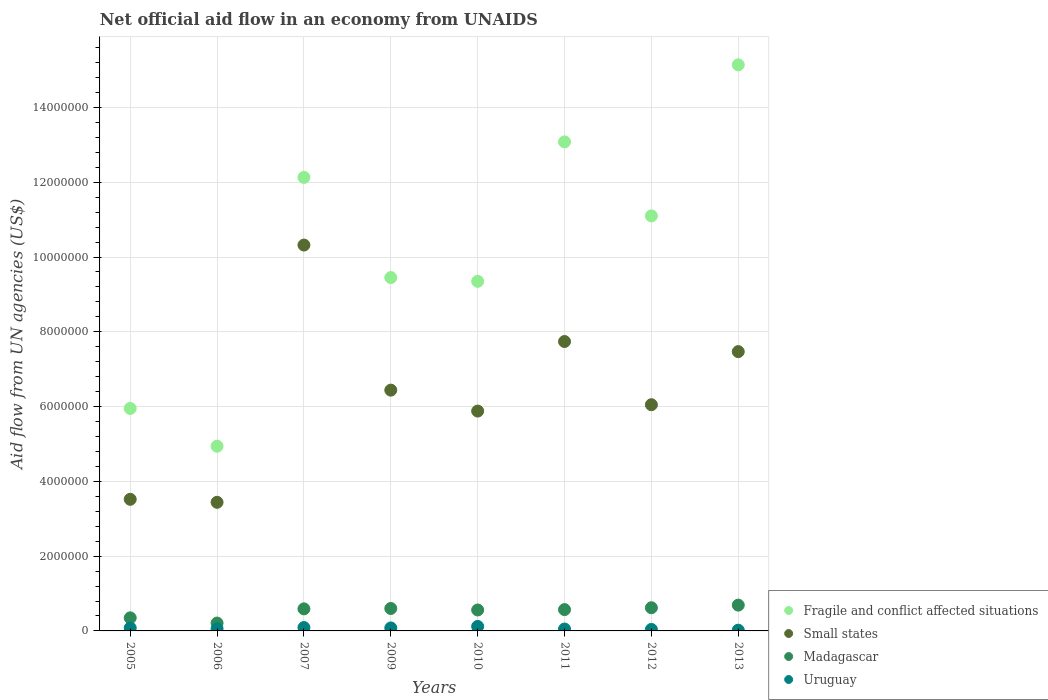How many different coloured dotlines are there?
Make the answer very short. 4. What is the net official aid flow in Fragile and conflict affected situations in 2012?
Your response must be concise. 1.11e+07. Across all years, what is the maximum net official aid flow in Fragile and conflict affected situations?
Make the answer very short. 1.51e+07. Across all years, what is the minimum net official aid flow in Small states?
Keep it short and to the point. 3.44e+06. In which year was the net official aid flow in Uruguay minimum?
Keep it short and to the point. 2013. What is the total net official aid flow in Uruguay in the graph?
Your answer should be very brief. 5.40e+05. What is the difference between the net official aid flow in Madagascar in 2006 and that in 2009?
Your answer should be compact. -3.90e+05. What is the difference between the net official aid flow in Uruguay in 2006 and the net official aid flow in Madagascar in 2011?
Offer a terse response. -5.10e+05. What is the average net official aid flow in Madagascar per year?
Provide a succinct answer. 5.24e+05. In the year 2012, what is the difference between the net official aid flow in Fragile and conflict affected situations and net official aid flow in Uruguay?
Make the answer very short. 1.11e+07. In how many years, is the net official aid flow in Fragile and conflict affected situations greater than 10400000 US$?
Your response must be concise. 4. What is the ratio of the net official aid flow in Madagascar in 2011 to that in 2013?
Give a very brief answer. 0.83. What is the difference between the highest and the lowest net official aid flow in Fragile and conflict affected situations?
Make the answer very short. 1.02e+07. Is it the case that in every year, the sum of the net official aid flow in Small states and net official aid flow in Madagascar  is greater than the net official aid flow in Uruguay?
Offer a terse response. Yes. Does the net official aid flow in Fragile and conflict affected situations monotonically increase over the years?
Offer a terse response. No. What is the difference between two consecutive major ticks on the Y-axis?
Your response must be concise. 2.00e+06. Does the graph contain grids?
Your response must be concise. Yes. How many legend labels are there?
Give a very brief answer. 4. What is the title of the graph?
Offer a terse response. Net official aid flow in an economy from UNAIDS. What is the label or title of the Y-axis?
Your answer should be compact. Aid flow from UN agencies (US$). What is the Aid flow from UN agencies (US$) in Fragile and conflict affected situations in 2005?
Keep it short and to the point. 5.95e+06. What is the Aid flow from UN agencies (US$) in Small states in 2005?
Make the answer very short. 3.52e+06. What is the Aid flow from UN agencies (US$) of Madagascar in 2005?
Offer a very short reply. 3.50e+05. What is the Aid flow from UN agencies (US$) of Fragile and conflict affected situations in 2006?
Provide a short and direct response. 4.94e+06. What is the Aid flow from UN agencies (US$) in Small states in 2006?
Make the answer very short. 3.44e+06. What is the Aid flow from UN agencies (US$) in Madagascar in 2006?
Ensure brevity in your answer.  2.10e+05. What is the Aid flow from UN agencies (US$) of Uruguay in 2006?
Your answer should be very brief. 6.00e+04. What is the Aid flow from UN agencies (US$) of Fragile and conflict affected situations in 2007?
Make the answer very short. 1.21e+07. What is the Aid flow from UN agencies (US$) in Small states in 2007?
Ensure brevity in your answer.  1.03e+07. What is the Aid flow from UN agencies (US$) in Madagascar in 2007?
Your answer should be compact. 5.90e+05. What is the Aid flow from UN agencies (US$) in Uruguay in 2007?
Keep it short and to the point. 9.00e+04. What is the Aid flow from UN agencies (US$) of Fragile and conflict affected situations in 2009?
Offer a very short reply. 9.45e+06. What is the Aid flow from UN agencies (US$) in Small states in 2009?
Your answer should be compact. 6.44e+06. What is the Aid flow from UN agencies (US$) in Uruguay in 2009?
Keep it short and to the point. 8.00e+04. What is the Aid flow from UN agencies (US$) of Fragile and conflict affected situations in 2010?
Provide a succinct answer. 9.35e+06. What is the Aid flow from UN agencies (US$) of Small states in 2010?
Provide a short and direct response. 5.88e+06. What is the Aid flow from UN agencies (US$) in Madagascar in 2010?
Your response must be concise. 5.60e+05. What is the Aid flow from UN agencies (US$) in Fragile and conflict affected situations in 2011?
Give a very brief answer. 1.31e+07. What is the Aid flow from UN agencies (US$) of Small states in 2011?
Offer a terse response. 7.74e+06. What is the Aid flow from UN agencies (US$) of Madagascar in 2011?
Make the answer very short. 5.70e+05. What is the Aid flow from UN agencies (US$) in Uruguay in 2011?
Keep it short and to the point. 5.00e+04. What is the Aid flow from UN agencies (US$) of Fragile and conflict affected situations in 2012?
Offer a terse response. 1.11e+07. What is the Aid flow from UN agencies (US$) of Small states in 2012?
Provide a succinct answer. 6.05e+06. What is the Aid flow from UN agencies (US$) of Madagascar in 2012?
Give a very brief answer. 6.20e+05. What is the Aid flow from UN agencies (US$) in Uruguay in 2012?
Give a very brief answer. 4.00e+04. What is the Aid flow from UN agencies (US$) in Fragile and conflict affected situations in 2013?
Make the answer very short. 1.51e+07. What is the Aid flow from UN agencies (US$) in Small states in 2013?
Your response must be concise. 7.47e+06. What is the Aid flow from UN agencies (US$) in Madagascar in 2013?
Offer a terse response. 6.90e+05. Across all years, what is the maximum Aid flow from UN agencies (US$) in Fragile and conflict affected situations?
Your response must be concise. 1.51e+07. Across all years, what is the maximum Aid flow from UN agencies (US$) in Small states?
Keep it short and to the point. 1.03e+07. Across all years, what is the maximum Aid flow from UN agencies (US$) in Madagascar?
Give a very brief answer. 6.90e+05. Across all years, what is the minimum Aid flow from UN agencies (US$) of Fragile and conflict affected situations?
Offer a terse response. 4.94e+06. Across all years, what is the minimum Aid flow from UN agencies (US$) in Small states?
Ensure brevity in your answer.  3.44e+06. Across all years, what is the minimum Aid flow from UN agencies (US$) of Madagascar?
Offer a very short reply. 2.10e+05. Across all years, what is the minimum Aid flow from UN agencies (US$) in Uruguay?
Your answer should be very brief. 2.00e+04. What is the total Aid flow from UN agencies (US$) in Fragile and conflict affected situations in the graph?
Your answer should be very brief. 8.11e+07. What is the total Aid flow from UN agencies (US$) of Small states in the graph?
Your answer should be compact. 5.09e+07. What is the total Aid flow from UN agencies (US$) of Madagascar in the graph?
Offer a terse response. 4.19e+06. What is the total Aid flow from UN agencies (US$) in Uruguay in the graph?
Provide a short and direct response. 5.40e+05. What is the difference between the Aid flow from UN agencies (US$) of Fragile and conflict affected situations in 2005 and that in 2006?
Keep it short and to the point. 1.01e+06. What is the difference between the Aid flow from UN agencies (US$) in Small states in 2005 and that in 2006?
Give a very brief answer. 8.00e+04. What is the difference between the Aid flow from UN agencies (US$) of Fragile and conflict affected situations in 2005 and that in 2007?
Offer a terse response. -6.18e+06. What is the difference between the Aid flow from UN agencies (US$) of Small states in 2005 and that in 2007?
Give a very brief answer. -6.80e+06. What is the difference between the Aid flow from UN agencies (US$) of Fragile and conflict affected situations in 2005 and that in 2009?
Your answer should be very brief. -3.50e+06. What is the difference between the Aid flow from UN agencies (US$) of Small states in 2005 and that in 2009?
Give a very brief answer. -2.92e+06. What is the difference between the Aid flow from UN agencies (US$) in Fragile and conflict affected situations in 2005 and that in 2010?
Your answer should be very brief. -3.40e+06. What is the difference between the Aid flow from UN agencies (US$) in Small states in 2005 and that in 2010?
Make the answer very short. -2.36e+06. What is the difference between the Aid flow from UN agencies (US$) of Madagascar in 2005 and that in 2010?
Ensure brevity in your answer.  -2.10e+05. What is the difference between the Aid flow from UN agencies (US$) of Fragile and conflict affected situations in 2005 and that in 2011?
Offer a terse response. -7.13e+06. What is the difference between the Aid flow from UN agencies (US$) in Small states in 2005 and that in 2011?
Provide a short and direct response. -4.22e+06. What is the difference between the Aid flow from UN agencies (US$) in Madagascar in 2005 and that in 2011?
Keep it short and to the point. -2.20e+05. What is the difference between the Aid flow from UN agencies (US$) in Uruguay in 2005 and that in 2011?
Provide a succinct answer. 3.00e+04. What is the difference between the Aid flow from UN agencies (US$) of Fragile and conflict affected situations in 2005 and that in 2012?
Ensure brevity in your answer.  -5.15e+06. What is the difference between the Aid flow from UN agencies (US$) in Small states in 2005 and that in 2012?
Offer a very short reply. -2.53e+06. What is the difference between the Aid flow from UN agencies (US$) in Madagascar in 2005 and that in 2012?
Give a very brief answer. -2.70e+05. What is the difference between the Aid flow from UN agencies (US$) of Fragile and conflict affected situations in 2005 and that in 2013?
Ensure brevity in your answer.  -9.19e+06. What is the difference between the Aid flow from UN agencies (US$) in Small states in 2005 and that in 2013?
Provide a short and direct response. -3.95e+06. What is the difference between the Aid flow from UN agencies (US$) in Fragile and conflict affected situations in 2006 and that in 2007?
Ensure brevity in your answer.  -7.19e+06. What is the difference between the Aid flow from UN agencies (US$) in Small states in 2006 and that in 2007?
Provide a short and direct response. -6.88e+06. What is the difference between the Aid flow from UN agencies (US$) of Madagascar in 2006 and that in 2007?
Your response must be concise. -3.80e+05. What is the difference between the Aid flow from UN agencies (US$) of Fragile and conflict affected situations in 2006 and that in 2009?
Provide a short and direct response. -4.51e+06. What is the difference between the Aid flow from UN agencies (US$) of Small states in 2006 and that in 2009?
Provide a short and direct response. -3.00e+06. What is the difference between the Aid flow from UN agencies (US$) in Madagascar in 2006 and that in 2009?
Give a very brief answer. -3.90e+05. What is the difference between the Aid flow from UN agencies (US$) of Uruguay in 2006 and that in 2009?
Make the answer very short. -2.00e+04. What is the difference between the Aid flow from UN agencies (US$) of Fragile and conflict affected situations in 2006 and that in 2010?
Provide a short and direct response. -4.41e+06. What is the difference between the Aid flow from UN agencies (US$) of Small states in 2006 and that in 2010?
Your response must be concise. -2.44e+06. What is the difference between the Aid flow from UN agencies (US$) of Madagascar in 2006 and that in 2010?
Ensure brevity in your answer.  -3.50e+05. What is the difference between the Aid flow from UN agencies (US$) of Fragile and conflict affected situations in 2006 and that in 2011?
Keep it short and to the point. -8.14e+06. What is the difference between the Aid flow from UN agencies (US$) in Small states in 2006 and that in 2011?
Make the answer very short. -4.30e+06. What is the difference between the Aid flow from UN agencies (US$) in Madagascar in 2006 and that in 2011?
Your answer should be compact. -3.60e+05. What is the difference between the Aid flow from UN agencies (US$) in Uruguay in 2006 and that in 2011?
Your answer should be compact. 10000. What is the difference between the Aid flow from UN agencies (US$) of Fragile and conflict affected situations in 2006 and that in 2012?
Your answer should be compact. -6.16e+06. What is the difference between the Aid flow from UN agencies (US$) in Small states in 2006 and that in 2012?
Keep it short and to the point. -2.61e+06. What is the difference between the Aid flow from UN agencies (US$) of Madagascar in 2006 and that in 2012?
Your answer should be compact. -4.10e+05. What is the difference between the Aid flow from UN agencies (US$) in Uruguay in 2006 and that in 2012?
Offer a very short reply. 2.00e+04. What is the difference between the Aid flow from UN agencies (US$) in Fragile and conflict affected situations in 2006 and that in 2013?
Offer a terse response. -1.02e+07. What is the difference between the Aid flow from UN agencies (US$) of Small states in 2006 and that in 2013?
Make the answer very short. -4.03e+06. What is the difference between the Aid flow from UN agencies (US$) in Madagascar in 2006 and that in 2013?
Offer a terse response. -4.80e+05. What is the difference between the Aid flow from UN agencies (US$) in Uruguay in 2006 and that in 2013?
Provide a succinct answer. 4.00e+04. What is the difference between the Aid flow from UN agencies (US$) of Fragile and conflict affected situations in 2007 and that in 2009?
Provide a succinct answer. 2.68e+06. What is the difference between the Aid flow from UN agencies (US$) of Small states in 2007 and that in 2009?
Offer a terse response. 3.88e+06. What is the difference between the Aid flow from UN agencies (US$) in Uruguay in 2007 and that in 2009?
Provide a succinct answer. 10000. What is the difference between the Aid flow from UN agencies (US$) of Fragile and conflict affected situations in 2007 and that in 2010?
Ensure brevity in your answer.  2.78e+06. What is the difference between the Aid flow from UN agencies (US$) in Small states in 2007 and that in 2010?
Offer a very short reply. 4.44e+06. What is the difference between the Aid flow from UN agencies (US$) of Uruguay in 2007 and that in 2010?
Your answer should be very brief. -3.00e+04. What is the difference between the Aid flow from UN agencies (US$) of Fragile and conflict affected situations in 2007 and that in 2011?
Offer a terse response. -9.50e+05. What is the difference between the Aid flow from UN agencies (US$) of Small states in 2007 and that in 2011?
Provide a succinct answer. 2.58e+06. What is the difference between the Aid flow from UN agencies (US$) in Madagascar in 2007 and that in 2011?
Provide a succinct answer. 2.00e+04. What is the difference between the Aid flow from UN agencies (US$) of Fragile and conflict affected situations in 2007 and that in 2012?
Provide a short and direct response. 1.03e+06. What is the difference between the Aid flow from UN agencies (US$) in Small states in 2007 and that in 2012?
Your response must be concise. 4.27e+06. What is the difference between the Aid flow from UN agencies (US$) in Madagascar in 2007 and that in 2012?
Keep it short and to the point. -3.00e+04. What is the difference between the Aid flow from UN agencies (US$) in Uruguay in 2007 and that in 2012?
Keep it short and to the point. 5.00e+04. What is the difference between the Aid flow from UN agencies (US$) in Fragile and conflict affected situations in 2007 and that in 2013?
Your response must be concise. -3.01e+06. What is the difference between the Aid flow from UN agencies (US$) of Small states in 2007 and that in 2013?
Give a very brief answer. 2.85e+06. What is the difference between the Aid flow from UN agencies (US$) in Madagascar in 2007 and that in 2013?
Offer a very short reply. -1.00e+05. What is the difference between the Aid flow from UN agencies (US$) of Small states in 2009 and that in 2010?
Your response must be concise. 5.60e+05. What is the difference between the Aid flow from UN agencies (US$) of Fragile and conflict affected situations in 2009 and that in 2011?
Your answer should be compact. -3.63e+06. What is the difference between the Aid flow from UN agencies (US$) of Small states in 2009 and that in 2011?
Give a very brief answer. -1.30e+06. What is the difference between the Aid flow from UN agencies (US$) of Uruguay in 2009 and that in 2011?
Your answer should be very brief. 3.00e+04. What is the difference between the Aid flow from UN agencies (US$) of Fragile and conflict affected situations in 2009 and that in 2012?
Offer a terse response. -1.65e+06. What is the difference between the Aid flow from UN agencies (US$) of Uruguay in 2009 and that in 2012?
Keep it short and to the point. 4.00e+04. What is the difference between the Aid flow from UN agencies (US$) of Fragile and conflict affected situations in 2009 and that in 2013?
Your answer should be very brief. -5.69e+06. What is the difference between the Aid flow from UN agencies (US$) of Small states in 2009 and that in 2013?
Your answer should be compact. -1.03e+06. What is the difference between the Aid flow from UN agencies (US$) of Madagascar in 2009 and that in 2013?
Give a very brief answer. -9.00e+04. What is the difference between the Aid flow from UN agencies (US$) of Uruguay in 2009 and that in 2013?
Your answer should be very brief. 6.00e+04. What is the difference between the Aid flow from UN agencies (US$) in Fragile and conflict affected situations in 2010 and that in 2011?
Provide a short and direct response. -3.73e+06. What is the difference between the Aid flow from UN agencies (US$) in Small states in 2010 and that in 2011?
Provide a succinct answer. -1.86e+06. What is the difference between the Aid flow from UN agencies (US$) of Madagascar in 2010 and that in 2011?
Ensure brevity in your answer.  -10000. What is the difference between the Aid flow from UN agencies (US$) of Fragile and conflict affected situations in 2010 and that in 2012?
Your answer should be very brief. -1.75e+06. What is the difference between the Aid flow from UN agencies (US$) in Madagascar in 2010 and that in 2012?
Your answer should be very brief. -6.00e+04. What is the difference between the Aid flow from UN agencies (US$) of Uruguay in 2010 and that in 2012?
Provide a short and direct response. 8.00e+04. What is the difference between the Aid flow from UN agencies (US$) of Fragile and conflict affected situations in 2010 and that in 2013?
Your answer should be compact. -5.79e+06. What is the difference between the Aid flow from UN agencies (US$) in Small states in 2010 and that in 2013?
Your answer should be very brief. -1.59e+06. What is the difference between the Aid flow from UN agencies (US$) of Madagascar in 2010 and that in 2013?
Ensure brevity in your answer.  -1.30e+05. What is the difference between the Aid flow from UN agencies (US$) in Fragile and conflict affected situations in 2011 and that in 2012?
Your answer should be compact. 1.98e+06. What is the difference between the Aid flow from UN agencies (US$) in Small states in 2011 and that in 2012?
Your response must be concise. 1.69e+06. What is the difference between the Aid flow from UN agencies (US$) in Madagascar in 2011 and that in 2012?
Offer a very short reply. -5.00e+04. What is the difference between the Aid flow from UN agencies (US$) in Uruguay in 2011 and that in 2012?
Keep it short and to the point. 10000. What is the difference between the Aid flow from UN agencies (US$) of Fragile and conflict affected situations in 2011 and that in 2013?
Your answer should be very brief. -2.06e+06. What is the difference between the Aid flow from UN agencies (US$) in Small states in 2011 and that in 2013?
Provide a short and direct response. 2.70e+05. What is the difference between the Aid flow from UN agencies (US$) of Madagascar in 2011 and that in 2013?
Provide a succinct answer. -1.20e+05. What is the difference between the Aid flow from UN agencies (US$) in Uruguay in 2011 and that in 2013?
Offer a very short reply. 3.00e+04. What is the difference between the Aid flow from UN agencies (US$) in Fragile and conflict affected situations in 2012 and that in 2013?
Provide a short and direct response. -4.04e+06. What is the difference between the Aid flow from UN agencies (US$) in Small states in 2012 and that in 2013?
Give a very brief answer. -1.42e+06. What is the difference between the Aid flow from UN agencies (US$) in Fragile and conflict affected situations in 2005 and the Aid flow from UN agencies (US$) in Small states in 2006?
Provide a short and direct response. 2.51e+06. What is the difference between the Aid flow from UN agencies (US$) of Fragile and conflict affected situations in 2005 and the Aid flow from UN agencies (US$) of Madagascar in 2006?
Your answer should be compact. 5.74e+06. What is the difference between the Aid flow from UN agencies (US$) of Fragile and conflict affected situations in 2005 and the Aid flow from UN agencies (US$) of Uruguay in 2006?
Keep it short and to the point. 5.89e+06. What is the difference between the Aid flow from UN agencies (US$) of Small states in 2005 and the Aid flow from UN agencies (US$) of Madagascar in 2006?
Offer a very short reply. 3.31e+06. What is the difference between the Aid flow from UN agencies (US$) in Small states in 2005 and the Aid flow from UN agencies (US$) in Uruguay in 2006?
Your answer should be very brief. 3.46e+06. What is the difference between the Aid flow from UN agencies (US$) in Fragile and conflict affected situations in 2005 and the Aid flow from UN agencies (US$) in Small states in 2007?
Offer a very short reply. -4.37e+06. What is the difference between the Aid flow from UN agencies (US$) of Fragile and conflict affected situations in 2005 and the Aid flow from UN agencies (US$) of Madagascar in 2007?
Keep it short and to the point. 5.36e+06. What is the difference between the Aid flow from UN agencies (US$) in Fragile and conflict affected situations in 2005 and the Aid flow from UN agencies (US$) in Uruguay in 2007?
Provide a succinct answer. 5.86e+06. What is the difference between the Aid flow from UN agencies (US$) of Small states in 2005 and the Aid flow from UN agencies (US$) of Madagascar in 2007?
Your response must be concise. 2.93e+06. What is the difference between the Aid flow from UN agencies (US$) in Small states in 2005 and the Aid flow from UN agencies (US$) in Uruguay in 2007?
Offer a terse response. 3.43e+06. What is the difference between the Aid flow from UN agencies (US$) in Fragile and conflict affected situations in 2005 and the Aid flow from UN agencies (US$) in Small states in 2009?
Provide a short and direct response. -4.90e+05. What is the difference between the Aid flow from UN agencies (US$) of Fragile and conflict affected situations in 2005 and the Aid flow from UN agencies (US$) of Madagascar in 2009?
Make the answer very short. 5.35e+06. What is the difference between the Aid flow from UN agencies (US$) in Fragile and conflict affected situations in 2005 and the Aid flow from UN agencies (US$) in Uruguay in 2009?
Your answer should be compact. 5.87e+06. What is the difference between the Aid flow from UN agencies (US$) in Small states in 2005 and the Aid flow from UN agencies (US$) in Madagascar in 2009?
Your answer should be compact. 2.92e+06. What is the difference between the Aid flow from UN agencies (US$) of Small states in 2005 and the Aid flow from UN agencies (US$) of Uruguay in 2009?
Your response must be concise. 3.44e+06. What is the difference between the Aid flow from UN agencies (US$) in Fragile and conflict affected situations in 2005 and the Aid flow from UN agencies (US$) in Madagascar in 2010?
Make the answer very short. 5.39e+06. What is the difference between the Aid flow from UN agencies (US$) in Fragile and conflict affected situations in 2005 and the Aid flow from UN agencies (US$) in Uruguay in 2010?
Provide a short and direct response. 5.83e+06. What is the difference between the Aid flow from UN agencies (US$) in Small states in 2005 and the Aid flow from UN agencies (US$) in Madagascar in 2010?
Offer a very short reply. 2.96e+06. What is the difference between the Aid flow from UN agencies (US$) of Small states in 2005 and the Aid flow from UN agencies (US$) of Uruguay in 2010?
Your answer should be very brief. 3.40e+06. What is the difference between the Aid flow from UN agencies (US$) in Madagascar in 2005 and the Aid flow from UN agencies (US$) in Uruguay in 2010?
Your answer should be very brief. 2.30e+05. What is the difference between the Aid flow from UN agencies (US$) in Fragile and conflict affected situations in 2005 and the Aid flow from UN agencies (US$) in Small states in 2011?
Keep it short and to the point. -1.79e+06. What is the difference between the Aid flow from UN agencies (US$) in Fragile and conflict affected situations in 2005 and the Aid flow from UN agencies (US$) in Madagascar in 2011?
Your answer should be very brief. 5.38e+06. What is the difference between the Aid flow from UN agencies (US$) of Fragile and conflict affected situations in 2005 and the Aid flow from UN agencies (US$) of Uruguay in 2011?
Your answer should be compact. 5.90e+06. What is the difference between the Aid flow from UN agencies (US$) in Small states in 2005 and the Aid flow from UN agencies (US$) in Madagascar in 2011?
Your response must be concise. 2.95e+06. What is the difference between the Aid flow from UN agencies (US$) in Small states in 2005 and the Aid flow from UN agencies (US$) in Uruguay in 2011?
Give a very brief answer. 3.47e+06. What is the difference between the Aid flow from UN agencies (US$) of Fragile and conflict affected situations in 2005 and the Aid flow from UN agencies (US$) of Small states in 2012?
Make the answer very short. -1.00e+05. What is the difference between the Aid flow from UN agencies (US$) in Fragile and conflict affected situations in 2005 and the Aid flow from UN agencies (US$) in Madagascar in 2012?
Keep it short and to the point. 5.33e+06. What is the difference between the Aid flow from UN agencies (US$) of Fragile and conflict affected situations in 2005 and the Aid flow from UN agencies (US$) of Uruguay in 2012?
Make the answer very short. 5.91e+06. What is the difference between the Aid flow from UN agencies (US$) in Small states in 2005 and the Aid flow from UN agencies (US$) in Madagascar in 2012?
Keep it short and to the point. 2.90e+06. What is the difference between the Aid flow from UN agencies (US$) of Small states in 2005 and the Aid flow from UN agencies (US$) of Uruguay in 2012?
Your answer should be very brief. 3.48e+06. What is the difference between the Aid flow from UN agencies (US$) of Fragile and conflict affected situations in 2005 and the Aid flow from UN agencies (US$) of Small states in 2013?
Provide a short and direct response. -1.52e+06. What is the difference between the Aid flow from UN agencies (US$) in Fragile and conflict affected situations in 2005 and the Aid flow from UN agencies (US$) in Madagascar in 2013?
Your response must be concise. 5.26e+06. What is the difference between the Aid flow from UN agencies (US$) of Fragile and conflict affected situations in 2005 and the Aid flow from UN agencies (US$) of Uruguay in 2013?
Offer a very short reply. 5.93e+06. What is the difference between the Aid flow from UN agencies (US$) of Small states in 2005 and the Aid flow from UN agencies (US$) of Madagascar in 2013?
Provide a succinct answer. 2.83e+06. What is the difference between the Aid flow from UN agencies (US$) of Small states in 2005 and the Aid flow from UN agencies (US$) of Uruguay in 2013?
Provide a short and direct response. 3.50e+06. What is the difference between the Aid flow from UN agencies (US$) in Fragile and conflict affected situations in 2006 and the Aid flow from UN agencies (US$) in Small states in 2007?
Provide a succinct answer. -5.38e+06. What is the difference between the Aid flow from UN agencies (US$) in Fragile and conflict affected situations in 2006 and the Aid flow from UN agencies (US$) in Madagascar in 2007?
Ensure brevity in your answer.  4.35e+06. What is the difference between the Aid flow from UN agencies (US$) of Fragile and conflict affected situations in 2006 and the Aid flow from UN agencies (US$) of Uruguay in 2007?
Give a very brief answer. 4.85e+06. What is the difference between the Aid flow from UN agencies (US$) of Small states in 2006 and the Aid flow from UN agencies (US$) of Madagascar in 2007?
Offer a very short reply. 2.85e+06. What is the difference between the Aid flow from UN agencies (US$) in Small states in 2006 and the Aid flow from UN agencies (US$) in Uruguay in 2007?
Make the answer very short. 3.35e+06. What is the difference between the Aid flow from UN agencies (US$) in Fragile and conflict affected situations in 2006 and the Aid flow from UN agencies (US$) in Small states in 2009?
Your response must be concise. -1.50e+06. What is the difference between the Aid flow from UN agencies (US$) of Fragile and conflict affected situations in 2006 and the Aid flow from UN agencies (US$) of Madagascar in 2009?
Make the answer very short. 4.34e+06. What is the difference between the Aid flow from UN agencies (US$) of Fragile and conflict affected situations in 2006 and the Aid flow from UN agencies (US$) of Uruguay in 2009?
Your response must be concise. 4.86e+06. What is the difference between the Aid flow from UN agencies (US$) in Small states in 2006 and the Aid flow from UN agencies (US$) in Madagascar in 2009?
Make the answer very short. 2.84e+06. What is the difference between the Aid flow from UN agencies (US$) of Small states in 2006 and the Aid flow from UN agencies (US$) of Uruguay in 2009?
Offer a very short reply. 3.36e+06. What is the difference between the Aid flow from UN agencies (US$) in Madagascar in 2006 and the Aid flow from UN agencies (US$) in Uruguay in 2009?
Make the answer very short. 1.30e+05. What is the difference between the Aid flow from UN agencies (US$) in Fragile and conflict affected situations in 2006 and the Aid flow from UN agencies (US$) in Small states in 2010?
Offer a very short reply. -9.40e+05. What is the difference between the Aid flow from UN agencies (US$) in Fragile and conflict affected situations in 2006 and the Aid flow from UN agencies (US$) in Madagascar in 2010?
Keep it short and to the point. 4.38e+06. What is the difference between the Aid flow from UN agencies (US$) in Fragile and conflict affected situations in 2006 and the Aid flow from UN agencies (US$) in Uruguay in 2010?
Provide a short and direct response. 4.82e+06. What is the difference between the Aid flow from UN agencies (US$) of Small states in 2006 and the Aid flow from UN agencies (US$) of Madagascar in 2010?
Make the answer very short. 2.88e+06. What is the difference between the Aid flow from UN agencies (US$) of Small states in 2006 and the Aid flow from UN agencies (US$) of Uruguay in 2010?
Offer a very short reply. 3.32e+06. What is the difference between the Aid flow from UN agencies (US$) in Madagascar in 2006 and the Aid flow from UN agencies (US$) in Uruguay in 2010?
Give a very brief answer. 9.00e+04. What is the difference between the Aid flow from UN agencies (US$) in Fragile and conflict affected situations in 2006 and the Aid flow from UN agencies (US$) in Small states in 2011?
Your response must be concise. -2.80e+06. What is the difference between the Aid flow from UN agencies (US$) in Fragile and conflict affected situations in 2006 and the Aid flow from UN agencies (US$) in Madagascar in 2011?
Provide a succinct answer. 4.37e+06. What is the difference between the Aid flow from UN agencies (US$) of Fragile and conflict affected situations in 2006 and the Aid flow from UN agencies (US$) of Uruguay in 2011?
Give a very brief answer. 4.89e+06. What is the difference between the Aid flow from UN agencies (US$) of Small states in 2006 and the Aid flow from UN agencies (US$) of Madagascar in 2011?
Give a very brief answer. 2.87e+06. What is the difference between the Aid flow from UN agencies (US$) of Small states in 2006 and the Aid flow from UN agencies (US$) of Uruguay in 2011?
Offer a terse response. 3.39e+06. What is the difference between the Aid flow from UN agencies (US$) in Madagascar in 2006 and the Aid flow from UN agencies (US$) in Uruguay in 2011?
Offer a very short reply. 1.60e+05. What is the difference between the Aid flow from UN agencies (US$) in Fragile and conflict affected situations in 2006 and the Aid flow from UN agencies (US$) in Small states in 2012?
Provide a succinct answer. -1.11e+06. What is the difference between the Aid flow from UN agencies (US$) of Fragile and conflict affected situations in 2006 and the Aid flow from UN agencies (US$) of Madagascar in 2012?
Give a very brief answer. 4.32e+06. What is the difference between the Aid flow from UN agencies (US$) of Fragile and conflict affected situations in 2006 and the Aid flow from UN agencies (US$) of Uruguay in 2012?
Ensure brevity in your answer.  4.90e+06. What is the difference between the Aid flow from UN agencies (US$) in Small states in 2006 and the Aid flow from UN agencies (US$) in Madagascar in 2012?
Your response must be concise. 2.82e+06. What is the difference between the Aid flow from UN agencies (US$) of Small states in 2006 and the Aid flow from UN agencies (US$) of Uruguay in 2012?
Give a very brief answer. 3.40e+06. What is the difference between the Aid flow from UN agencies (US$) in Fragile and conflict affected situations in 2006 and the Aid flow from UN agencies (US$) in Small states in 2013?
Your answer should be very brief. -2.53e+06. What is the difference between the Aid flow from UN agencies (US$) in Fragile and conflict affected situations in 2006 and the Aid flow from UN agencies (US$) in Madagascar in 2013?
Keep it short and to the point. 4.25e+06. What is the difference between the Aid flow from UN agencies (US$) of Fragile and conflict affected situations in 2006 and the Aid flow from UN agencies (US$) of Uruguay in 2013?
Keep it short and to the point. 4.92e+06. What is the difference between the Aid flow from UN agencies (US$) of Small states in 2006 and the Aid flow from UN agencies (US$) of Madagascar in 2013?
Make the answer very short. 2.75e+06. What is the difference between the Aid flow from UN agencies (US$) in Small states in 2006 and the Aid flow from UN agencies (US$) in Uruguay in 2013?
Your response must be concise. 3.42e+06. What is the difference between the Aid flow from UN agencies (US$) in Madagascar in 2006 and the Aid flow from UN agencies (US$) in Uruguay in 2013?
Your response must be concise. 1.90e+05. What is the difference between the Aid flow from UN agencies (US$) in Fragile and conflict affected situations in 2007 and the Aid flow from UN agencies (US$) in Small states in 2009?
Offer a terse response. 5.69e+06. What is the difference between the Aid flow from UN agencies (US$) of Fragile and conflict affected situations in 2007 and the Aid flow from UN agencies (US$) of Madagascar in 2009?
Your response must be concise. 1.15e+07. What is the difference between the Aid flow from UN agencies (US$) in Fragile and conflict affected situations in 2007 and the Aid flow from UN agencies (US$) in Uruguay in 2009?
Make the answer very short. 1.20e+07. What is the difference between the Aid flow from UN agencies (US$) in Small states in 2007 and the Aid flow from UN agencies (US$) in Madagascar in 2009?
Provide a short and direct response. 9.72e+06. What is the difference between the Aid flow from UN agencies (US$) in Small states in 2007 and the Aid flow from UN agencies (US$) in Uruguay in 2009?
Your answer should be compact. 1.02e+07. What is the difference between the Aid flow from UN agencies (US$) in Madagascar in 2007 and the Aid flow from UN agencies (US$) in Uruguay in 2009?
Your answer should be very brief. 5.10e+05. What is the difference between the Aid flow from UN agencies (US$) of Fragile and conflict affected situations in 2007 and the Aid flow from UN agencies (US$) of Small states in 2010?
Your answer should be compact. 6.25e+06. What is the difference between the Aid flow from UN agencies (US$) of Fragile and conflict affected situations in 2007 and the Aid flow from UN agencies (US$) of Madagascar in 2010?
Keep it short and to the point. 1.16e+07. What is the difference between the Aid flow from UN agencies (US$) of Fragile and conflict affected situations in 2007 and the Aid flow from UN agencies (US$) of Uruguay in 2010?
Offer a very short reply. 1.20e+07. What is the difference between the Aid flow from UN agencies (US$) in Small states in 2007 and the Aid flow from UN agencies (US$) in Madagascar in 2010?
Your response must be concise. 9.76e+06. What is the difference between the Aid flow from UN agencies (US$) in Small states in 2007 and the Aid flow from UN agencies (US$) in Uruguay in 2010?
Your response must be concise. 1.02e+07. What is the difference between the Aid flow from UN agencies (US$) of Madagascar in 2007 and the Aid flow from UN agencies (US$) of Uruguay in 2010?
Your answer should be very brief. 4.70e+05. What is the difference between the Aid flow from UN agencies (US$) in Fragile and conflict affected situations in 2007 and the Aid flow from UN agencies (US$) in Small states in 2011?
Make the answer very short. 4.39e+06. What is the difference between the Aid flow from UN agencies (US$) of Fragile and conflict affected situations in 2007 and the Aid flow from UN agencies (US$) of Madagascar in 2011?
Provide a succinct answer. 1.16e+07. What is the difference between the Aid flow from UN agencies (US$) of Fragile and conflict affected situations in 2007 and the Aid flow from UN agencies (US$) of Uruguay in 2011?
Your answer should be very brief. 1.21e+07. What is the difference between the Aid flow from UN agencies (US$) of Small states in 2007 and the Aid flow from UN agencies (US$) of Madagascar in 2011?
Ensure brevity in your answer.  9.75e+06. What is the difference between the Aid flow from UN agencies (US$) in Small states in 2007 and the Aid flow from UN agencies (US$) in Uruguay in 2011?
Keep it short and to the point. 1.03e+07. What is the difference between the Aid flow from UN agencies (US$) of Madagascar in 2007 and the Aid flow from UN agencies (US$) of Uruguay in 2011?
Your answer should be very brief. 5.40e+05. What is the difference between the Aid flow from UN agencies (US$) in Fragile and conflict affected situations in 2007 and the Aid flow from UN agencies (US$) in Small states in 2012?
Provide a succinct answer. 6.08e+06. What is the difference between the Aid flow from UN agencies (US$) of Fragile and conflict affected situations in 2007 and the Aid flow from UN agencies (US$) of Madagascar in 2012?
Ensure brevity in your answer.  1.15e+07. What is the difference between the Aid flow from UN agencies (US$) in Fragile and conflict affected situations in 2007 and the Aid flow from UN agencies (US$) in Uruguay in 2012?
Offer a very short reply. 1.21e+07. What is the difference between the Aid flow from UN agencies (US$) of Small states in 2007 and the Aid flow from UN agencies (US$) of Madagascar in 2012?
Offer a terse response. 9.70e+06. What is the difference between the Aid flow from UN agencies (US$) of Small states in 2007 and the Aid flow from UN agencies (US$) of Uruguay in 2012?
Provide a short and direct response. 1.03e+07. What is the difference between the Aid flow from UN agencies (US$) in Fragile and conflict affected situations in 2007 and the Aid flow from UN agencies (US$) in Small states in 2013?
Your answer should be compact. 4.66e+06. What is the difference between the Aid flow from UN agencies (US$) in Fragile and conflict affected situations in 2007 and the Aid flow from UN agencies (US$) in Madagascar in 2013?
Make the answer very short. 1.14e+07. What is the difference between the Aid flow from UN agencies (US$) of Fragile and conflict affected situations in 2007 and the Aid flow from UN agencies (US$) of Uruguay in 2013?
Give a very brief answer. 1.21e+07. What is the difference between the Aid flow from UN agencies (US$) in Small states in 2007 and the Aid flow from UN agencies (US$) in Madagascar in 2013?
Your response must be concise. 9.63e+06. What is the difference between the Aid flow from UN agencies (US$) in Small states in 2007 and the Aid flow from UN agencies (US$) in Uruguay in 2013?
Your response must be concise. 1.03e+07. What is the difference between the Aid flow from UN agencies (US$) of Madagascar in 2007 and the Aid flow from UN agencies (US$) of Uruguay in 2013?
Offer a terse response. 5.70e+05. What is the difference between the Aid flow from UN agencies (US$) in Fragile and conflict affected situations in 2009 and the Aid flow from UN agencies (US$) in Small states in 2010?
Provide a succinct answer. 3.57e+06. What is the difference between the Aid flow from UN agencies (US$) of Fragile and conflict affected situations in 2009 and the Aid flow from UN agencies (US$) of Madagascar in 2010?
Offer a very short reply. 8.89e+06. What is the difference between the Aid flow from UN agencies (US$) in Fragile and conflict affected situations in 2009 and the Aid flow from UN agencies (US$) in Uruguay in 2010?
Your answer should be compact. 9.33e+06. What is the difference between the Aid flow from UN agencies (US$) in Small states in 2009 and the Aid flow from UN agencies (US$) in Madagascar in 2010?
Give a very brief answer. 5.88e+06. What is the difference between the Aid flow from UN agencies (US$) in Small states in 2009 and the Aid flow from UN agencies (US$) in Uruguay in 2010?
Ensure brevity in your answer.  6.32e+06. What is the difference between the Aid flow from UN agencies (US$) of Madagascar in 2009 and the Aid flow from UN agencies (US$) of Uruguay in 2010?
Give a very brief answer. 4.80e+05. What is the difference between the Aid flow from UN agencies (US$) in Fragile and conflict affected situations in 2009 and the Aid flow from UN agencies (US$) in Small states in 2011?
Make the answer very short. 1.71e+06. What is the difference between the Aid flow from UN agencies (US$) of Fragile and conflict affected situations in 2009 and the Aid flow from UN agencies (US$) of Madagascar in 2011?
Offer a very short reply. 8.88e+06. What is the difference between the Aid flow from UN agencies (US$) of Fragile and conflict affected situations in 2009 and the Aid flow from UN agencies (US$) of Uruguay in 2011?
Give a very brief answer. 9.40e+06. What is the difference between the Aid flow from UN agencies (US$) in Small states in 2009 and the Aid flow from UN agencies (US$) in Madagascar in 2011?
Offer a very short reply. 5.87e+06. What is the difference between the Aid flow from UN agencies (US$) in Small states in 2009 and the Aid flow from UN agencies (US$) in Uruguay in 2011?
Offer a terse response. 6.39e+06. What is the difference between the Aid flow from UN agencies (US$) of Madagascar in 2009 and the Aid flow from UN agencies (US$) of Uruguay in 2011?
Provide a succinct answer. 5.50e+05. What is the difference between the Aid flow from UN agencies (US$) in Fragile and conflict affected situations in 2009 and the Aid flow from UN agencies (US$) in Small states in 2012?
Keep it short and to the point. 3.40e+06. What is the difference between the Aid flow from UN agencies (US$) in Fragile and conflict affected situations in 2009 and the Aid flow from UN agencies (US$) in Madagascar in 2012?
Ensure brevity in your answer.  8.83e+06. What is the difference between the Aid flow from UN agencies (US$) in Fragile and conflict affected situations in 2009 and the Aid flow from UN agencies (US$) in Uruguay in 2012?
Offer a very short reply. 9.41e+06. What is the difference between the Aid flow from UN agencies (US$) of Small states in 2009 and the Aid flow from UN agencies (US$) of Madagascar in 2012?
Ensure brevity in your answer.  5.82e+06. What is the difference between the Aid flow from UN agencies (US$) in Small states in 2009 and the Aid flow from UN agencies (US$) in Uruguay in 2012?
Your answer should be compact. 6.40e+06. What is the difference between the Aid flow from UN agencies (US$) in Madagascar in 2009 and the Aid flow from UN agencies (US$) in Uruguay in 2012?
Offer a very short reply. 5.60e+05. What is the difference between the Aid flow from UN agencies (US$) in Fragile and conflict affected situations in 2009 and the Aid flow from UN agencies (US$) in Small states in 2013?
Offer a terse response. 1.98e+06. What is the difference between the Aid flow from UN agencies (US$) in Fragile and conflict affected situations in 2009 and the Aid flow from UN agencies (US$) in Madagascar in 2013?
Your response must be concise. 8.76e+06. What is the difference between the Aid flow from UN agencies (US$) of Fragile and conflict affected situations in 2009 and the Aid flow from UN agencies (US$) of Uruguay in 2013?
Make the answer very short. 9.43e+06. What is the difference between the Aid flow from UN agencies (US$) in Small states in 2009 and the Aid flow from UN agencies (US$) in Madagascar in 2013?
Offer a terse response. 5.75e+06. What is the difference between the Aid flow from UN agencies (US$) of Small states in 2009 and the Aid flow from UN agencies (US$) of Uruguay in 2013?
Keep it short and to the point. 6.42e+06. What is the difference between the Aid flow from UN agencies (US$) of Madagascar in 2009 and the Aid flow from UN agencies (US$) of Uruguay in 2013?
Make the answer very short. 5.80e+05. What is the difference between the Aid flow from UN agencies (US$) of Fragile and conflict affected situations in 2010 and the Aid flow from UN agencies (US$) of Small states in 2011?
Ensure brevity in your answer.  1.61e+06. What is the difference between the Aid flow from UN agencies (US$) in Fragile and conflict affected situations in 2010 and the Aid flow from UN agencies (US$) in Madagascar in 2011?
Offer a terse response. 8.78e+06. What is the difference between the Aid flow from UN agencies (US$) of Fragile and conflict affected situations in 2010 and the Aid flow from UN agencies (US$) of Uruguay in 2011?
Your response must be concise. 9.30e+06. What is the difference between the Aid flow from UN agencies (US$) in Small states in 2010 and the Aid flow from UN agencies (US$) in Madagascar in 2011?
Your answer should be very brief. 5.31e+06. What is the difference between the Aid flow from UN agencies (US$) in Small states in 2010 and the Aid flow from UN agencies (US$) in Uruguay in 2011?
Offer a very short reply. 5.83e+06. What is the difference between the Aid flow from UN agencies (US$) of Madagascar in 2010 and the Aid flow from UN agencies (US$) of Uruguay in 2011?
Make the answer very short. 5.10e+05. What is the difference between the Aid flow from UN agencies (US$) of Fragile and conflict affected situations in 2010 and the Aid flow from UN agencies (US$) of Small states in 2012?
Make the answer very short. 3.30e+06. What is the difference between the Aid flow from UN agencies (US$) in Fragile and conflict affected situations in 2010 and the Aid flow from UN agencies (US$) in Madagascar in 2012?
Offer a terse response. 8.73e+06. What is the difference between the Aid flow from UN agencies (US$) of Fragile and conflict affected situations in 2010 and the Aid flow from UN agencies (US$) of Uruguay in 2012?
Ensure brevity in your answer.  9.31e+06. What is the difference between the Aid flow from UN agencies (US$) in Small states in 2010 and the Aid flow from UN agencies (US$) in Madagascar in 2012?
Give a very brief answer. 5.26e+06. What is the difference between the Aid flow from UN agencies (US$) of Small states in 2010 and the Aid flow from UN agencies (US$) of Uruguay in 2012?
Provide a succinct answer. 5.84e+06. What is the difference between the Aid flow from UN agencies (US$) of Madagascar in 2010 and the Aid flow from UN agencies (US$) of Uruguay in 2012?
Provide a short and direct response. 5.20e+05. What is the difference between the Aid flow from UN agencies (US$) of Fragile and conflict affected situations in 2010 and the Aid flow from UN agencies (US$) of Small states in 2013?
Make the answer very short. 1.88e+06. What is the difference between the Aid flow from UN agencies (US$) in Fragile and conflict affected situations in 2010 and the Aid flow from UN agencies (US$) in Madagascar in 2013?
Your answer should be very brief. 8.66e+06. What is the difference between the Aid flow from UN agencies (US$) in Fragile and conflict affected situations in 2010 and the Aid flow from UN agencies (US$) in Uruguay in 2013?
Offer a very short reply. 9.33e+06. What is the difference between the Aid flow from UN agencies (US$) of Small states in 2010 and the Aid flow from UN agencies (US$) of Madagascar in 2013?
Your answer should be very brief. 5.19e+06. What is the difference between the Aid flow from UN agencies (US$) of Small states in 2010 and the Aid flow from UN agencies (US$) of Uruguay in 2013?
Keep it short and to the point. 5.86e+06. What is the difference between the Aid flow from UN agencies (US$) of Madagascar in 2010 and the Aid flow from UN agencies (US$) of Uruguay in 2013?
Provide a short and direct response. 5.40e+05. What is the difference between the Aid flow from UN agencies (US$) in Fragile and conflict affected situations in 2011 and the Aid flow from UN agencies (US$) in Small states in 2012?
Your response must be concise. 7.03e+06. What is the difference between the Aid flow from UN agencies (US$) in Fragile and conflict affected situations in 2011 and the Aid flow from UN agencies (US$) in Madagascar in 2012?
Your answer should be very brief. 1.25e+07. What is the difference between the Aid flow from UN agencies (US$) in Fragile and conflict affected situations in 2011 and the Aid flow from UN agencies (US$) in Uruguay in 2012?
Give a very brief answer. 1.30e+07. What is the difference between the Aid flow from UN agencies (US$) in Small states in 2011 and the Aid flow from UN agencies (US$) in Madagascar in 2012?
Ensure brevity in your answer.  7.12e+06. What is the difference between the Aid flow from UN agencies (US$) of Small states in 2011 and the Aid flow from UN agencies (US$) of Uruguay in 2012?
Your response must be concise. 7.70e+06. What is the difference between the Aid flow from UN agencies (US$) of Madagascar in 2011 and the Aid flow from UN agencies (US$) of Uruguay in 2012?
Provide a short and direct response. 5.30e+05. What is the difference between the Aid flow from UN agencies (US$) in Fragile and conflict affected situations in 2011 and the Aid flow from UN agencies (US$) in Small states in 2013?
Keep it short and to the point. 5.61e+06. What is the difference between the Aid flow from UN agencies (US$) of Fragile and conflict affected situations in 2011 and the Aid flow from UN agencies (US$) of Madagascar in 2013?
Your response must be concise. 1.24e+07. What is the difference between the Aid flow from UN agencies (US$) of Fragile and conflict affected situations in 2011 and the Aid flow from UN agencies (US$) of Uruguay in 2013?
Provide a short and direct response. 1.31e+07. What is the difference between the Aid flow from UN agencies (US$) of Small states in 2011 and the Aid flow from UN agencies (US$) of Madagascar in 2013?
Your answer should be compact. 7.05e+06. What is the difference between the Aid flow from UN agencies (US$) of Small states in 2011 and the Aid flow from UN agencies (US$) of Uruguay in 2013?
Keep it short and to the point. 7.72e+06. What is the difference between the Aid flow from UN agencies (US$) of Fragile and conflict affected situations in 2012 and the Aid flow from UN agencies (US$) of Small states in 2013?
Keep it short and to the point. 3.63e+06. What is the difference between the Aid flow from UN agencies (US$) in Fragile and conflict affected situations in 2012 and the Aid flow from UN agencies (US$) in Madagascar in 2013?
Offer a very short reply. 1.04e+07. What is the difference between the Aid flow from UN agencies (US$) in Fragile and conflict affected situations in 2012 and the Aid flow from UN agencies (US$) in Uruguay in 2013?
Offer a terse response. 1.11e+07. What is the difference between the Aid flow from UN agencies (US$) of Small states in 2012 and the Aid flow from UN agencies (US$) of Madagascar in 2013?
Give a very brief answer. 5.36e+06. What is the difference between the Aid flow from UN agencies (US$) of Small states in 2012 and the Aid flow from UN agencies (US$) of Uruguay in 2013?
Provide a short and direct response. 6.03e+06. What is the average Aid flow from UN agencies (US$) of Fragile and conflict affected situations per year?
Ensure brevity in your answer.  1.01e+07. What is the average Aid flow from UN agencies (US$) in Small states per year?
Keep it short and to the point. 6.36e+06. What is the average Aid flow from UN agencies (US$) in Madagascar per year?
Keep it short and to the point. 5.24e+05. What is the average Aid flow from UN agencies (US$) in Uruguay per year?
Your response must be concise. 6.75e+04. In the year 2005, what is the difference between the Aid flow from UN agencies (US$) of Fragile and conflict affected situations and Aid flow from UN agencies (US$) of Small states?
Your response must be concise. 2.43e+06. In the year 2005, what is the difference between the Aid flow from UN agencies (US$) in Fragile and conflict affected situations and Aid flow from UN agencies (US$) in Madagascar?
Give a very brief answer. 5.60e+06. In the year 2005, what is the difference between the Aid flow from UN agencies (US$) of Fragile and conflict affected situations and Aid flow from UN agencies (US$) of Uruguay?
Offer a terse response. 5.87e+06. In the year 2005, what is the difference between the Aid flow from UN agencies (US$) of Small states and Aid flow from UN agencies (US$) of Madagascar?
Offer a terse response. 3.17e+06. In the year 2005, what is the difference between the Aid flow from UN agencies (US$) of Small states and Aid flow from UN agencies (US$) of Uruguay?
Give a very brief answer. 3.44e+06. In the year 2006, what is the difference between the Aid flow from UN agencies (US$) in Fragile and conflict affected situations and Aid flow from UN agencies (US$) in Small states?
Provide a short and direct response. 1.50e+06. In the year 2006, what is the difference between the Aid flow from UN agencies (US$) of Fragile and conflict affected situations and Aid flow from UN agencies (US$) of Madagascar?
Provide a succinct answer. 4.73e+06. In the year 2006, what is the difference between the Aid flow from UN agencies (US$) of Fragile and conflict affected situations and Aid flow from UN agencies (US$) of Uruguay?
Your answer should be very brief. 4.88e+06. In the year 2006, what is the difference between the Aid flow from UN agencies (US$) of Small states and Aid flow from UN agencies (US$) of Madagascar?
Provide a succinct answer. 3.23e+06. In the year 2006, what is the difference between the Aid flow from UN agencies (US$) in Small states and Aid flow from UN agencies (US$) in Uruguay?
Provide a succinct answer. 3.38e+06. In the year 2007, what is the difference between the Aid flow from UN agencies (US$) in Fragile and conflict affected situations and Aid flow from UN agencies (US$) in Small states?
Your answer should be very brief. 1.81e+06. In the year 2007, what is the difference between the Aid flow from UN agencies (US$) of Fragile and conflict affected situations and Aid flow from UN agencies (US$) of Madagascar?
Your answer should be very brief. 1.15e+07. In the year 2007, what is the difference between the Aid flow from UN agencies (US$) in Fragile and conflict affected situations and Aid flow from UN agencies (US$) in Uruguay?
Keep it short and to the point. 1.20e+07. In the year 2007, what is the difference between the Aid flow from UN agencies (US$) of Small states and Aid flow from UN agencies (US$) of Madagascar?
Your response must be concise. 9.73e+06. In the year 2007, what is the difference between the Aid flow from UN agencies (US$) in Small states and Aid flow from UN agencies (US$) in Uruguay?
Your answer should be very brief. 1.02e+07. In the year 2007, what is the difference between the Aid flow from UN agencies (US$) in Madagascar and Aid flow from UN agencies (US$) in Uruguay?
Ensure brevity in your answer.  5.00e+05. In the year 2009, what is the difference between the Aid flow from UN agencies (US$) in Fragile and conflict affected situations and Aid flow from UN agencies (US$) in Small states?
Offer a very short reply. 3.01e+06. In the year 2009, what is the difference between the Aid flow from UN agencies (US$) of Fragile and conflict affected situations and Aid flow from UN agencies (US$) of Madagascar?
Give a very brief answer. 8.85e+06. In the year 2009, what is the difference between the Aid flow from UN agencies (US$) in Fragile and conflict affected situations and Aid flow from UN agencies (US$) in Uruguay?
Your response must be concise. 9.37e+06. In the year 2009, what is the difference between the Aid flow from UN agencies (US$) of Small states and Aid flow from UN agencies (US$) of Madagascar?
Offer a terse response. 5.84e+06. In the year 2009, what is the difference between the Aid flow from UN agencies (US$) of Small states and Aid flow from UN agencies (US$) of Uruguay?
Make the answer very short. 6.36e+06. In the year 2009, what is the difference between the Aid flow from UN agencies (US$) of Madagascar and Aid flow from UN agencies (US$) of Uruguay?
Your answer should be compact. 5.20e+05. In the year 2010, what is the difference between the Aid flow from UN agencies (US$) in Fragile and conflict affected situations and Aid flow from UN agencies (US$) in Small states?
Your answer should be very brief. 3.47e+06. In the year 2010, what is the difference between the Aid flow from UN agencies (US$) of Fragile and conflict affected situations and Aid flow from UN agencies (US$) of Madagascar?
Offer a terse response. 8.79e+06. In the year 2010, what is the difference between the Aid flow from UN agencies (US$) in Fragile and conflict affected situations and Aid flow from UN agencies (US$) in Uruguay?
Your answer should be compact. 9.23e+06. In the year 2010, what is the difference between the Aid flow from UN agencies (US$) of Small states and Aid flow from UN agencies (US$) of Madagascar?
Keep it short and to the point. 5.32e+06. In the year 2010, what is the difference between the Aid flow from UN agencies (US$) of Small states and Aid flow from UN agencies (US$) of Uruguay?
Make the answer very short. 5.76e+06. In the year 2010, what is the difference between the Aid flow from UN agencies (US$) of Madagascar and Aid flow from UN agencies (US$) of Uruguay?
Give a very brief answer. 4.40e+05. In the year 2011, what is the difference between the Aid flow from UN agencies (US$) of Fragile and conflict affected situations and Aid flow from UN agencies (US$) of Small states?
Make the answer very short. 5.34e+06. In the year 2011, what is the difference between the Aid flow from UN agencies (US$) in Fragile and conflict affected situations and Aid flow from UN agencies (US$) in Madagascar?
Offer a terse response. 1.25e+07. In the year 2011, what is the difference between the Aid flow from UN agencies (US$) of Fragile and conflict affected situations and Aid flow from UN agencies (US$) of Uruguay?
Provide a short and direct response. 1.30e+07. In the year 2011, what is the difference between the Aid flow from UN agencies (US$) of Small states and Aid flow from UN agencies (US$) of Madagascar?
Give a very brief answer. 7.17e+06. In the year 2011, what is the difference between the Aid flow from UN agencies (US$) in Small states and Aid flow from UN agencies (US$) in Uruguay?
Your response must be concise. 7.69e+06. In the year 2011, what is the difference between the Aid flow from UN agencies (US$) of Madagascar and Aid flow from UN agencies (US$) of Uruguay?
Your response must be concise. 5.20e+05. In the year 2012, what is the difference between the Aid flow from UN agencies (US$) of Fragile and conflict affected situations and Aid flow from UN agencies (US$) of Small states?
Give a very brief answer. 5.05e+06. In the year 2012, what is the difference between the Aid flow from UN agencies (US$) of Fragile and conflict affected situations and Aid flow from UN agencies (US$) of Madagascar?
Provide a succinct answer. 1.05e+07. In the year 2012, what is the difference between the Aid flow from UN agencies (US$) of Fragile and conflict affected situations and Aid flow from UN agencies (US$) of Uruguay?
Provide a short and direct response. 1.11e+07. In the year 2012, what is the difference between the Aid flow from UN agencies (US$) of Small states and Aid flow from UN agencies (US$) of Madagascar?
Your answer should be compact. 5.43e+06. In the year 2012, what is the difference between the Aid flow from UN agencies (US$) of Small states and Aid flow from UN agencies (US$) of Uruguay?
Ensure brevity in your answer.  6.01e+06. In the year 2012, what is the difference between the Aid flow from UN agencies (US$) in Madagascar and Aid flow from UN agencies (US$) in Uruguay?
Your answer should be very brief. 5.80e+05. In the year 2013, what is the difference between the Aid flow from UN agencies (US$) in Fragile and conflict affected situations and Aid flow from UN agencies (US$) in Small states?
Provide a succinct answer. 7.67e+06. In the year 2013, what is the difference between the Aid flow from UN agencies (US$) of Fragile and conflict affected situations and Aid flow from UN agencies (US$) of Madagascar?
Keep it short and to the point. 1.44e+07. In the year 2013, what is the difference between the Aid flow from UN agencies (US$) of Fragile and conflict affected situations and Aid flow from UN agencies (US$) of Uruguay?
Offer a terse response. 1.51e+07. In the year 2013, what is the difference between the Aid flow from UN agencies (US$) of Small states and Aid flow from UN agencies (US$) of Madagascar?
Keep it short and to the point. 6.78e+06. In the year 2013, what is the difference between the Aid flow from UN agencies (US$) in Small states and Aid flow from UN agencies (US$) in Uruguay?
Give a very brief answer. 7.45e+06. In the year 2013, what is the difference between the Aid flow from UN agencies (US$) in Madagascar and Aid flow from UN agencies (US$) in Uruguay?
Offer a terse response. 6.70e+05. What is the ratio of the Aid flow from UN agencies (US$) of Fragile and conflict affected situations in 2005 to that in 2006?
Your answer should be very brief. 1.2. What is the ratio of the Aid flow from UN agencies (US$) in Small states in 2005 to that in 2006?
Ensure brevity in your answer.  1.02. What is the ratio of the Aid flow from UN agencies (US$) of Uruguay in 2005 to that in 2006?
Ensure brevity in your answer.  1.33. What is the ratio of the Aid flow from UN agencies (US$) of Fragile and conflict affected situations in 2005 to that in 2007?
Offer a terse response. 0.49. What is the ratio of the Aid flow from UN agencies (US$) in Small states in 2005 to that in 2007?
Your response must be concise. 0.34. What is the ratio of the Aid flow from UN agencies (US$) of Madagascar in 2005 to that in 2007?
Give a very brief answer. 0.59. What is the ratio of the Aid flow from UN agencies (US$) of Fragile and conflict affected situations in 2005 to that in 2009?
Give a very brief answer. 0.63. What is the ratio of the Aid flow from UN agencies (US$) in Small states in 2005 to that in 2009?
Provide a short and direct response. 0.55. What is the ratio of the Aid flow from UN agencies (US$) of Madagascar in 2005 to that in 2009?
Make the answer very short. 0.58. What is the ratio of the Aid flow from UN agencies (US$) of Uruguay in 2005 to that in 2009?
Provide a succinct answer. 1. What is the ratio of the Aid flow from UN agencies (US$) in Fragile and conflict affected situations in 2005 to that in 2010?
Your answer should be very brief. 0.64. What is the ratio of the Aid flow from UN agencies (US$) in Small states in 2005 to that in 2010?
Your answer should be compact. 0.6. What is the ratio of the Aid flow from UN agencies (US$) in Madagascar in 2005 to that in 2010?
Your answer should be compact. 0.62. What is the ratio of the Aid flow from UN agencies (US$) of Uruguay in 2005 to that in 2010?
Give a very brief answer. 0.67. What is the ratio of the Aid flow from UN agencies (US$) in Fragile and conflict affected situations in 2005 to that in 2011?
Keep it short and to the point. 0.45. What is the ratio of the Aid flow from UN agencies (US$) of Small states in 2005 to that in 2011?
Your response must be concise. 0.45. What is the ratio of the Aid flow from UN agencies (US$) of Madagascar in 2005 to that in 2011?
Your response must be concise. 0.61. What is the ratio of the Aid flow from UN agencies (US$) in Uruguay in 2005 to that in 2011?
Offer a terse response. 1.6. What is the ratio of the Aid flow from UN agencies (US$) in Fragile and conflict affected situations in 2005 to that in 2012?
Provide a short and direct response. 0.54. What is the ratio of the Aid flow from UN agencies (US$) in Small states in 2005 to that in 2012?
Offer a terse response. 0.58. What is the ratio of the Aid flow from UN agencies (US$) of Madagascar in 2005 to that in 2012?
Your answer should be very brief. 0.56. What is the ratio of the Aid flow from UN agencies (US$) of Fragile and conflict affected situations in 2005 to that in 2013?
Ensure brevity in your answer.  0.39. What is the ratio of the Aid flow from UN agencies (US$) in Small states in 2005 to that in 2013?
Provide a short and direct response. 0.47. What is the ratio of the Aid flow from UN agencies (US$) of Madagascar in 2005 to that in 2013?
Provide a succinct answer. 0.51. What is the ratio of the Aid flow from UN agencies (US$) of Fragile and conflict affected situations in 2006 to that in 2007?
Your response must be concise. 0.41. What is the ratio of the Aid flow from UN agencies (US$) of Small states in 2006 to that in 2007?
Your answer should be very brief. 0.33. What is the ratio of the Aid flow from UN agencies (US$) of Madagascar in 2006 to that in 2007?
Your answer should be compact. 0.36. What is the ratio of the Aid flow from UN agencies (US$) of Uruguay in 2006 to that in 2007?
Your answer should be very brief. 0.67. What is the ratio of the Aid flow from UN agencies (US$) in Fragile and conflict affected situations in 2006 to that in 2009?
Your answer should be compact. 0.52. What is the ratio of the Aid flow from UN agencies (US$) in Small states in 2006 to that in 2009?
Provide a succinct answer. 0.53. What is the ratio of the Aid flow from UN agencies (US$) of Madagascar in 2006 to that in 2009?
Offer a terse response. 0.35. What is the ratio of the Aid flow from UN agencies (US$) of Uruguay in 2006 to that in 2009?
Ensure brevity in your answer.  0.75. What is the ratio of the Aid flow from UN agencies (US$) of Fragile and conflict affected situations in 2006 to that in 2010?
Ensure brevity in your answer.  0.53. What is the ratio of the Aid flow from UN agencies (US$) of Small states in 2006 to that in 2010?
Provide a succinct answer. 0.58. What is the ratio of the Aid flow from UN agencies (US$) of Uruguay in 2006 to that in 2010?
Provide a succinct answer. 0.5. What is the ratio of the Aid flow from UN agencies (US$) in Fragile and conflict affected situations in 2006 to that in 2011?
Offer a terse response. 0.38. What is the ratio of the Aid flow from UN agencies (US$) in Small states in 2006 to that in 2011?
Offer a very short reply. 0.44. What is the ratio of the Aid flow from UN agencies (US$) in Madagascar in 2006 to that in 2011?
Ensure brevity in your answer.  0.37. What is the ratio of the Aid flow from UN agencies (US$) of Fragile and conflict affected situations in 2006 to that in 2012?
Give a very brief answer. 0.45. What is the ratio of the Aid flow from UN agencies (US$) in Small states in 2006 to that in 2012?
Ensure brevity in your answer.  0.57. What is the ratio of the Aid flow from UN agencies (US$) in Madagascar in 2006 to that in 2012?
Make the answer very short. 0.34. What is the ratio of the Aid flow from UN agencies (US$) of Uruguay in 2006 to that in 2012?
Provide a short and direct response. 1.5. What is the ratio of the Aid flow from UN agencies (US$) in Fragile and conflict affected situations in 2006 to that in 2013?
Keep it short and to the point. 0.33. What is the ratio of the Aid flow from UN agencies (US$) of Small states in 2006 to that in 2013?
Make the answer very short. 0.46. What is the ratio of the Aid flow from UN agencies (US$) of Madagascar in 2006 to that in 2013?
Keep it short and to the point. 0.3. What is the ratio of the Aid flow from UN agencies (US$) in Fragile and conflict affected situations in 2007 to that in 2009?
Provide a succinct answer. 1.28. What is the ratio of the Aid flow from UN agencies (US$) in Small states in 2007 to that in 2009?
Your response must be concise. 1.6. What is the ratio of the Aid flow from UN agencies (US$) of Madagascar in 2007 to that in 2009?
Give a very brief answer. 0.98. What is the ratio of the Aid flow from UN agencies (US$) of Uruguay in 2007 to that in 2009?
Your answer should be very brief. 1.12. What is the ratio of the Aid flow from UN agencies (US$) in Fragile and conflict affected situations in 2007 to that in 2010?
Offer a very short reply. 1.3. What is the ratio of the Aid flow from UN agencies (US$) of Small states in 2007 to that in 2010?
Keep it short and to the point. 1.76. What is the ratio of the Aid flow from UN agencies (US$) in Madagascar in 2007 to that in 2010?
Your answer should be very brief. 1.05. What is the ratio of the Aid flow from UN agencies (US$) of Uruguay in 2007 to that in 2010?
Provide a succinct answer. 0.75. What is the ratio of the Aid flow from UN agencies (US$) in Fragile and conflict affected situations in 2007 to that in 2011?
Offer a very short reply. 0.93. What is the ratio of the Aid flow from UN agencies (US$) of Small states in 2007 to that in 2011?
Provide a succinct answer. 1.33. What is the ratio of the Aid flow from UN agencies (US$) in Madagascar in 2007 to that in 2011?
Ensure brevity in your answer.  1.04. What is the ratio of the Aid flow from UN agencies (US$) in Uruguay in 2007 to that in 2011?
Your answer should be very brief. 1.8. What is the ratio of the Aid flow from UN agencies (US$) in Fragile and conflict affected situations in 2007 to that in 2012?
Your answer should be compact. 1.09. What is the ratio of the Aid flow from UN agencies (US$) of Small states in 2007 to that in 2012?
Your answer should be compact. 1.71. What is the ratio of the Aid flow from UN agencies (US$) of Madagascar in 2007 to that in 2012?
Your answer should be very brief. 0.95. What is the ratio of the Aid flow from UN agencies (US$) in Uruguay in 2007 to that in 2012?
Provide a short and direct response. 2.25. What is the ratio of the Aid flow from UN agencies (US$) of Fragile and conflict affected situations in 2007 to that in 2013?
Keep it short and to the point. 0.8. What is the ratio of the Aid flow from UN agencies (US$) of Small states in 2007 to that in 2013?
Your response must be concise. 1.38. What is the ratio of the Aid flow from UN agencies (US$) of Madagascar in 2007 to that in 2013?
Provide a succinct answer. 0.86. What is the ratio of the Aid flow from UN agencies (US$) of Uruguay in 2007 to that in 2013?
Offer a terse response. 4.5. What is the ratio of the Aid flow from UN agencies (US$) of Fragile and conflict affected situations in 2009 to that in 2010?
Make the answer very short. 1.01. What is the ratio of the Aid flow from UN agencies (US$) in Small states in 2009 to that in 2010?
Offer a terse response. 1.1. What is the ratio of the Aid flow from UN agencies (US$) in Madagascar in 2009 to that in 2010?
Your answer should be very brief. 1.07. What is the ratio of the Aid flow from UN agencies (US$) of Uruguay in 2009 to that in 2010?
Provide a short and direct response. 0.67. What is the ratio of the Aid flow from UN agencies (US$) of Fragile and conflict affected situations in 2009 to that in 2011?
Offer a very short reply. 0.72. What is the ratio of the Aid flow from UN agencies (US$) in Small states in 2009 to that in 2011?
Ensure brevity in your answer.  0.83. What is the ratio of the Aid flow from UN agencies (US$) of Madagascar in 2009 to that in 2011?
Offer a very short reply. 1.05. What is the ratio of the Aid flow from UN agencies (US$) of Fragile and conflict affected situations in 2009 to that in 2012?
Keep it short and to the point. 0.85. What is the ratio of the Aid flow from UN agencies (US$) of Small states in 2009 to that in 2012?
Make the answer very short. 1.06. What is the ratio of the Aid flow from UN agencies (US$) of Fragile and conflict affected situations in 2009 to that in 2013?
Ensure brevity in your answer.  0.62. What is the ratio of the Aid flow from UN agencies (US$) in Small states in 2009 to that in 2013?
Ensure brevity in your answer.  0.86. What is the ratio of the Aid flow from UN agencies (US$) of Madagascar in 2009 to that in 2013?
Your answer should be compact. 0.87. What is the ratio of the Aid flow from UN agencies (US$) in Uruguay in 2009 to that in 2013?
Your answer should be very brief. 4. What is the ratio of the Aid flow from UN agencies (US$) of Fragile and conflict affected situations in 2010 to that in 2011?
Your answer should be compact. 0.71. What is the ratio of the Aid flow from UN agencies (US$) of Small states in 2010 to that in 2011?
Your answer should be very brief. 0.76. What is the ratio of the Aid flow from UN agencies (US$) in Madagascar in 2010 to that in 2011?
Provide a succinct answer. 0.98. What is the ratio of the Aid flow from UN agencies (US$) in Uruguay in 2010 to that in 2011?
Provide a succinct answer. 2.4. What is the ratio of the Aid flow from UN agencies (US$) in Fragile and conflict affected situations in 2010 to that in 2012?
Make the answer very short. 0.84. What is the ratio of the Aid flow from UN agencies (US$) of Small states in 2010 to that in 2012?
Provide a succinct answer. 0.97. What is the ratio of the Aid flow from UN agencies (US$) in Madagascar in 2010 to that in 2012?
Offer a terse response. 0.9. What is the ratio of the Aid flow from UN agencies (US$) of Uruguay in 2010 to that in 2012?
Ensure brevity in your answer.  3. What is the ratio of the Aid flow from UN agencies (US$) of Fragile and conflict affected situations in 2010 to that in 2013?
Ensure brevity in your answer.  0.62. What is the ratio of the Aid flow from UN agencies (US$) of Small states in 2010 to that in 2013?
Offer a terse response. 0.79. What is the ratio of the Aid flow from UN agencies (US$) in Madagascar in 2010 to that in 2013?
Your response must be concise. 0.81. What is the ratio of the Aid flow from UN agencies (US$) in Uruguay in 2010 to that in 2013?
Provide a succinct answer. 6. What is the ratio of the Aid flow from UN agencies (US$) in Fragile and conflict affected situations in 2011 to that in 2012?
Your answer should be very brief. 1.18. What is the ratio of the Aid flow from UN agencies (US$) of Small states in 2011 to that in 2012?
Ensure brevity in your answer.  1.28. What is the ratio of the Aid flow from UN agencies (US$) in Madagascar in 2011 to that in 2012?
Ensure brevity in your answer.  0.92. What is the ratio of the Aid flow from UN agencies (US$) of Uruguay in 2011 to that in 2012?
Make the answer very short. 1.25. What is the ratio of the Aid flow from UN agencies (US$) of Fragile and conflict affected situations in 2011 to that in 2013?
Give a very brief answer. 0.86. What is the ratio of the Aid flow from UN agencies (US$) of Small states in 2011 to that in 2013?
Provide a succinct answer. 1.04. What is the ratio of the Aid flow from UN agencies (US$) of Madagascar in 2011 to that in 2013?
Provide a short and direct response. 0.83. What is the ratio of the Aid flow from UN agencies (US$) in Fragile and conflict affected situations in 2012 to that in 2013?
Give a very brief answer. 0.73. What is the ratio of the Aid flow from UN agencies (US$) of Small states in 2012 to that in 2013?
Ensure brevity in your answer.  0.81. What is the ratio of the Aid flow from UN agencies (US$) of Madagascar in 2012 to that in 2013?
Your answer should be compact. 0.9. What is the ratio of the Aid flow from UN agencies (US$) of Uruguay in 2012 to that in 2013?
Your answer should be compact. 2. What is the difference between the highest and the second highest Aid flow from UN agencies (US$) of Fragile and conflict affected situations?
Offer a very short reply. 2.06e+06. What is the difference between the highest and the second highest Aid flow from UN agencies (US$) in Small states?
Make the answer very short. 2.58e+06. What is the difference between the highest and the second highest Aid flow from UN agencies (US$) of Madagascar?
Ensure brevity in your answer.  7.00e+04. What is the difference between the highest and the lowest Aid flow from UN agencies (US$) of Fragile and conflict affected situations?
Your answer should be compact. 1.02e+07. What is the difference between the highest and the lowest Aid flow from UN agencies (US$) of Small states?
Offer a very short reply. 6.88e+06. What is the difference between the highest and the lowest Aid flow from UN agencies (US$) of Madagascar?
Make the answer very short. 4.80e+05. What is the difference between the highest and the lowest Aid flow from UN agencies (US$) of Uruguay?
Provide a succinct answer. 1.00e+05. 